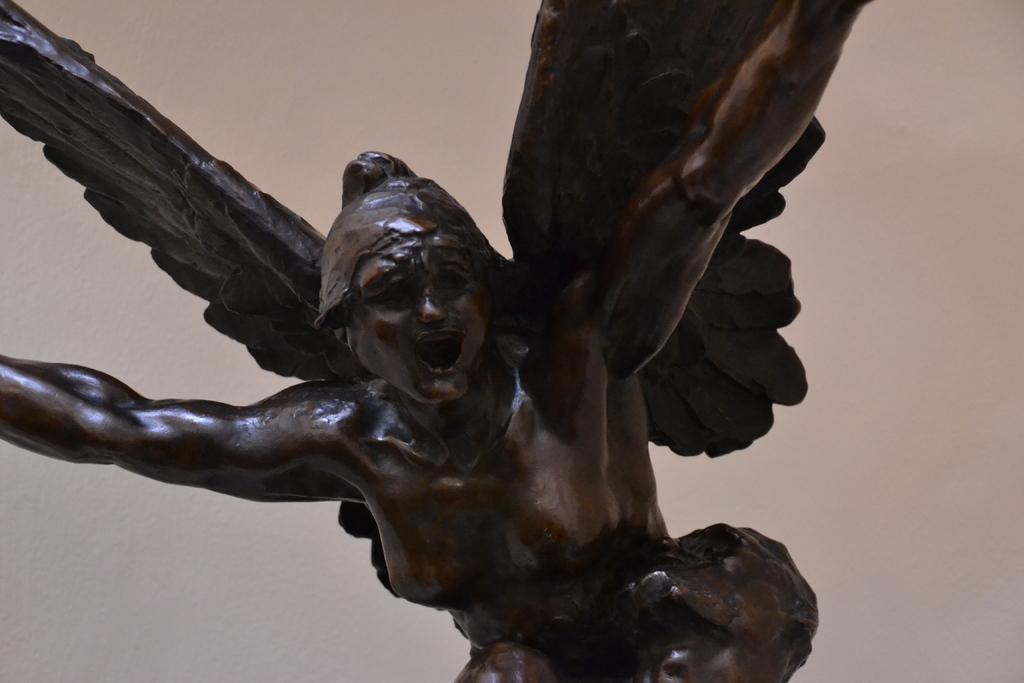In one or two sentences, can you explain what this image depicts? The picture consists of a sculpture. In the background it is well. 